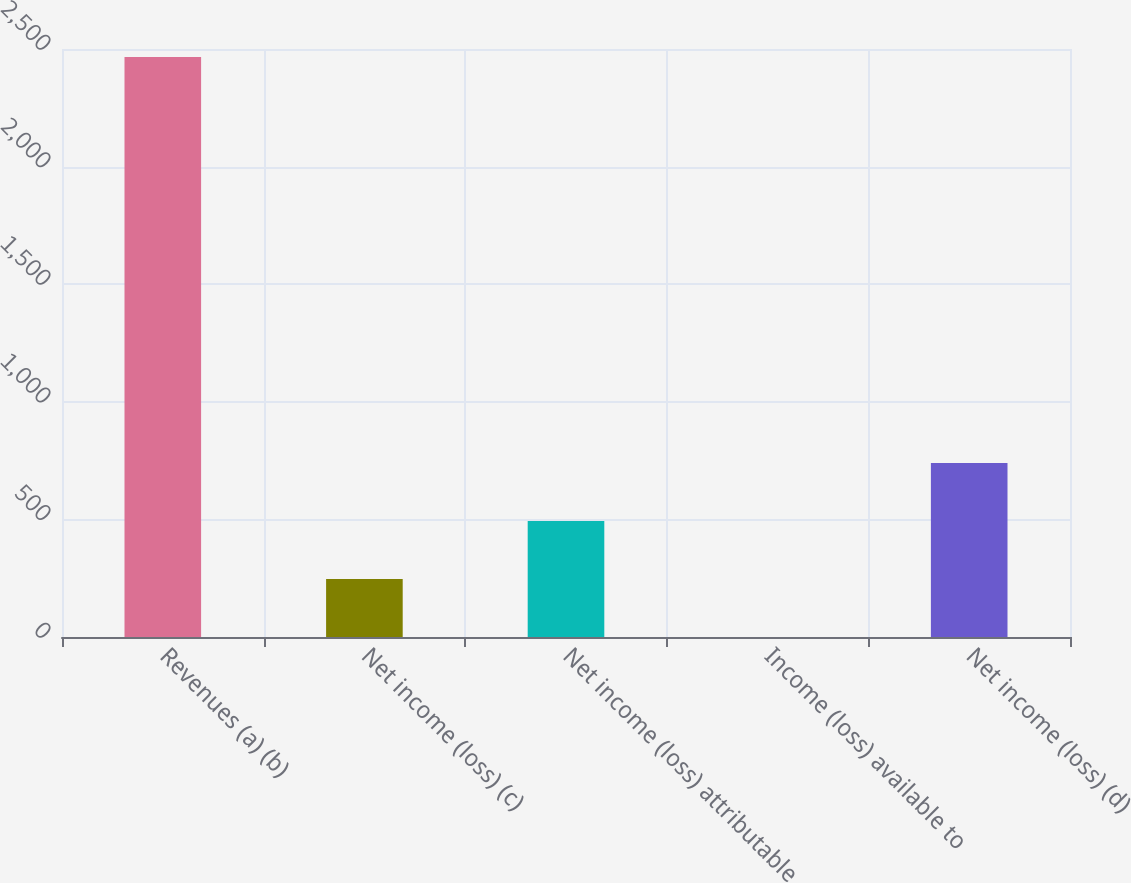Convert chart. <chart><loc_0><loc_0><loc_500><loc_500><bar_chart><fcel>Revenues (a) (b)<fcel>Net income (loss) (c)<fcel>Net income (loss) attributable<fcel>Income (loss) available to<fcel>Net income (loss) (d)<nl><fcel>2466<fcel>246.68<fcel>493.27<fcel>0.09<fcel>739.86<nl></chart> 